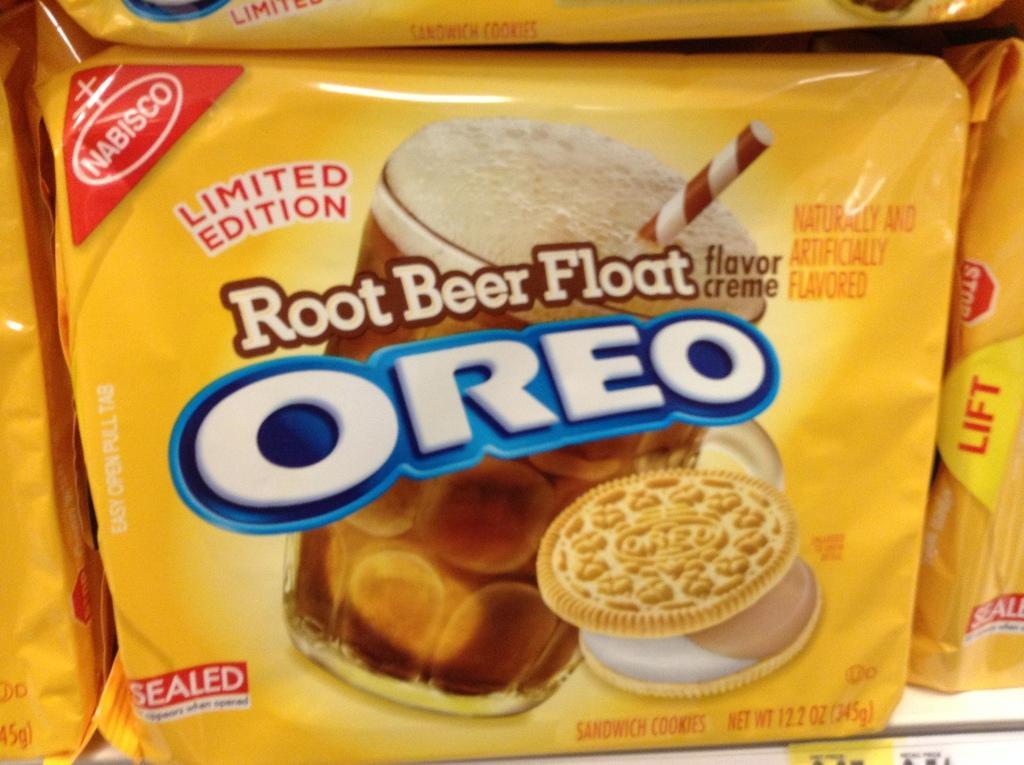How would you summarize this image in a sentence or two? In this image, there is packet contains a glass, biscuits and some text. 